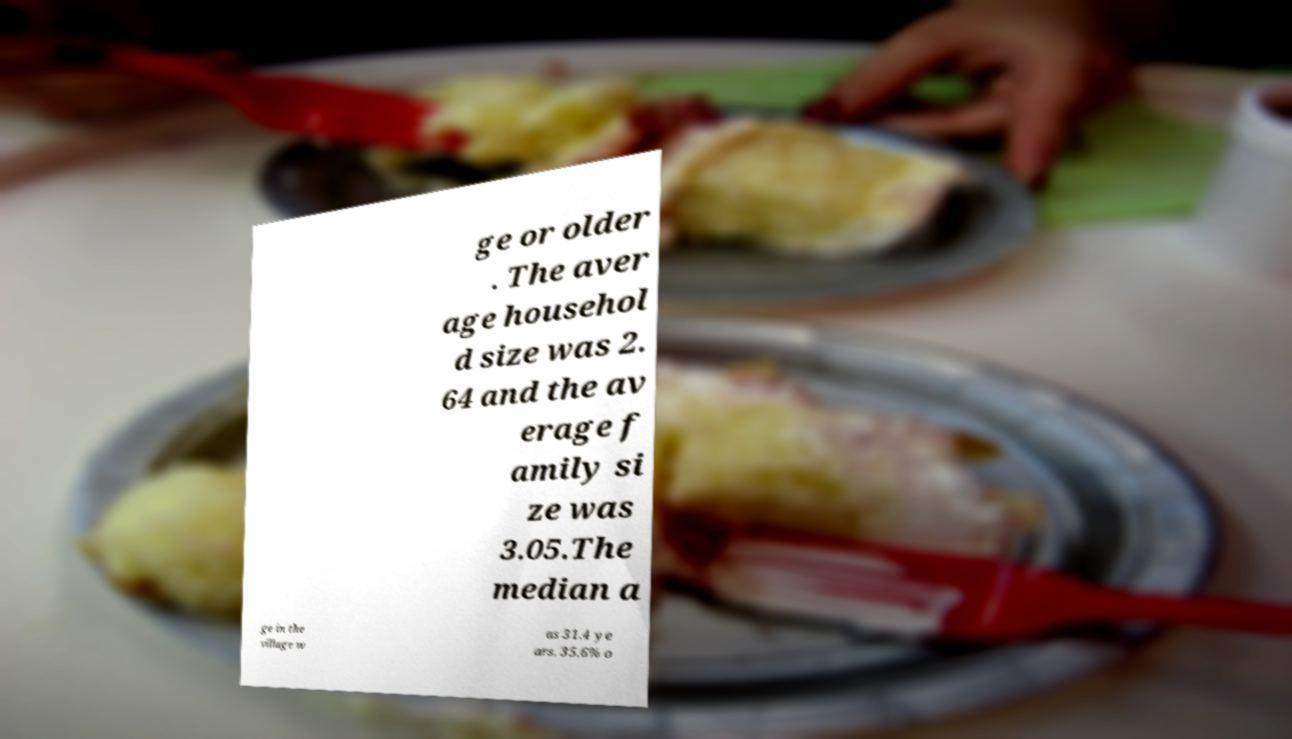Could you extract and type out the text from this image? ge or older . The aver age househol d size was 2. 64 and the av erage f amily si ze was 3.05.The median a ge in the village w as 31.4 ye ars. 35.6% o 